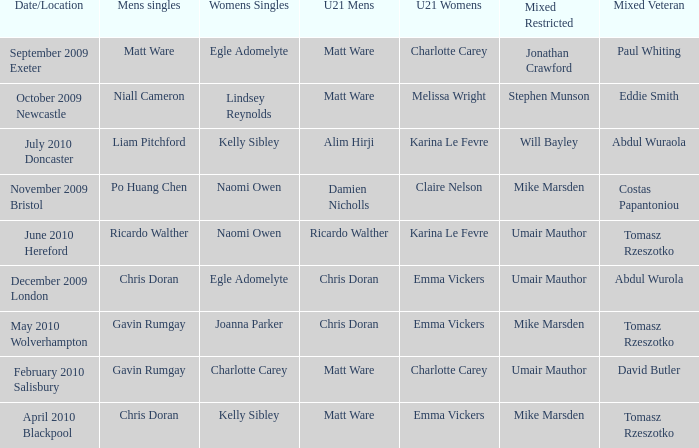Who won the mixed restricted when Tomasz Rzeszotko won the mixed veteran and Karina Le Fevre won the U21 womens? Umair Mauthor. 